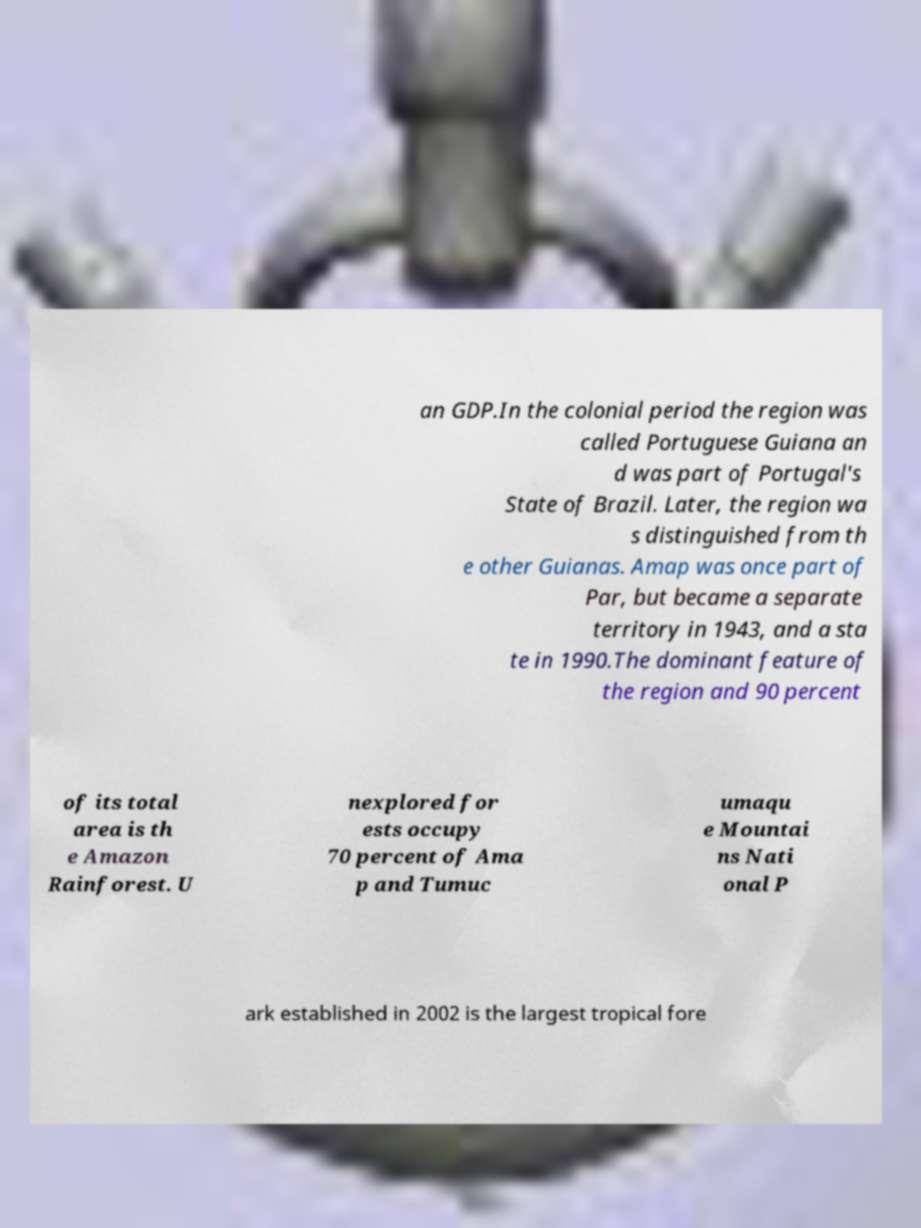Could you extract and type out the text from this image? an GDP.In the colonial period the region was called Portuguese Guiana an d was part of Portugal's State of Brazil. Later, the region wa s distinguished from th e other Guianas. Amap was once part of Par, but became a separate territory in 1943, and a sta te in 1990.The dominant feature of the region and 90 percent of its total area is th e Amazon Rainforest. U nexplored for ests occupy 70 percent of Ama p and Tumuc umaqu e Mountai ns Nati onal P ark established in 2002 is the largest tropical fore 